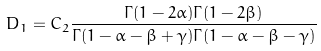Convert formula to latex. <formula><loc_0><loc_0><loc_500><loc_500>D _ { 1 } = C _ { 2 } \frac { \Gamma ( 1 - 2 \alpha ) \Gamma ( 1 - 2 \beta ) } { \Gamma ( 1 - \alpha - \beta + \gamma ) \Gamma ( 1 - \alpha - \beta - \gamma ) }</formula> 